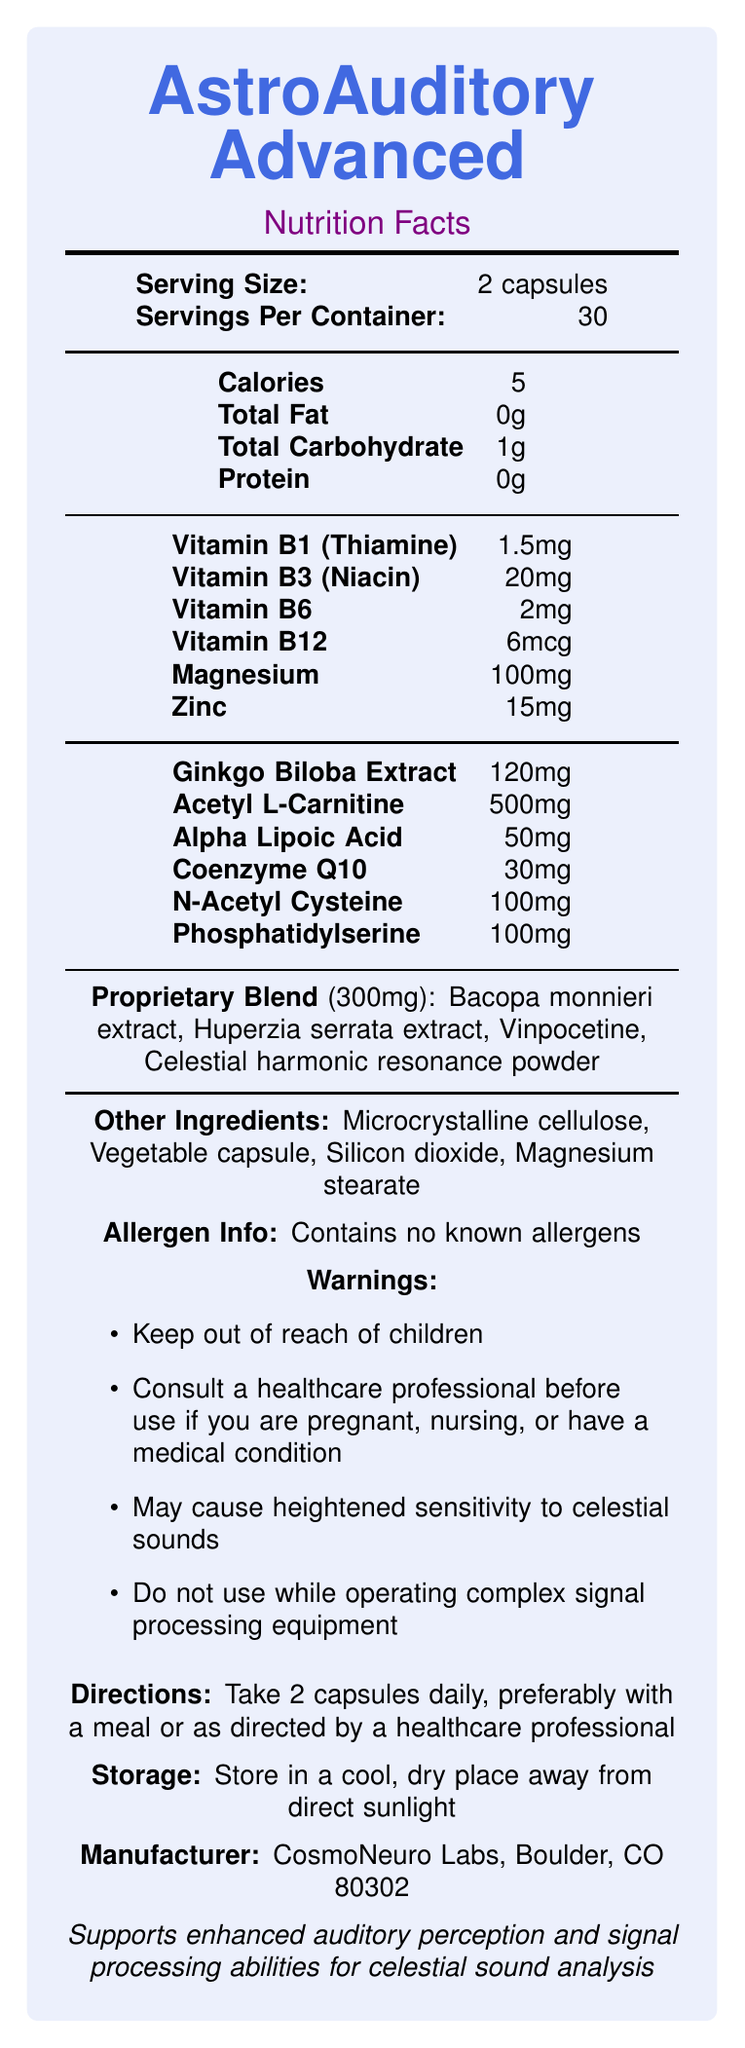what is the serving size? The serving size is clearly listed as "2 capsules" under the "Serving Size" section.
Answer: 2 capsules how many calories are in one serving? The calories per serving are listed as "5" in the Nutrition Facts section.
Answer: 5 which vitamins are included in the supplement? The listed vitamins under Nutrition Facts are Vitamin B1 (Thiamine), Vitamin B3 (Niacin), Vitamin B6, and Vitamin B12.
Answer: Vitamin B1 (Thiamine), Vitamin B3 (Niacin), Vitamin B6, Vitamin B12 how much Magnesium is in each serving? The amount of Magnesium per serving is stated as "100mg" in the Nutrition Facts section.
Answer: 100mg are there any known allergens in this supplement? The document explicitly states that the supplement "Contains no known allergens".
Answer: Contains no known allergens which of the following is part of the proprietary blend? A. Coenzyme Q10 B. Ginkgo Biloba Extract C. Vinpocetine Vinpocetine is listed as one of the components in the proprietary blend.
Answer: C. Vinpocetine how should the supplement be stored? A. In a warm place B. In a humid place C. In a cool, dry place The storage instructions specify that the supplement should be stored "in a cool, dry place away from direct sunlight."
Answer: C. In a cool, dry place can pregnant women take this supplement without consulting a healthcare professional? One of the listed warnings is to "consult a healthcare professional before use if you are pregnant".
Answer: No does this product contain protein? The Nutrition Facts indicate that the protein content per serving is "0g".
Answer: No how many capsules should be taken daily? The directions state to "Take 2 capsules daily".
Answer: 2 who is the manufacturer of this supplement? The manufacturer information provided is "CosmoNeuro Labs, Boulder, CO 80302".
Answer: CosmoNeuro Labs, Boulder, CO 80302 summarize the overall purpose of AstroAuditory Advanced. The document claims that AstroAuditory Advanced "supports enhanced auditory perception and signal processing abilities for celestial sound analysis."
Answer: Supports enhanced auditory perception and signal processing abilities for celestial sound analysis how many components are in the Proprietary Blend? The Proprietary Blend contains Bacopa monnieri extract, Huperzia serrata extract, Vinpocetine, and Celestial harmonic resonance powder, making a total of four components.
Answer: Four how many vitamins are listed in the Nutrition Facts section? The Nutrition Facts list four vitamins: Vitamin B1 (Thiamine), Vitamin B3 (Niacin), Vitamin B6, and Vitamin B12.
Answer: Four is there any claim about the impact on celestial sounds? The document mentions "may cause heightened sensitivity to celestial sounds" in the warnings section.
Answer: Yes what is the serving size for this supplement in capsules? The serving size section states that it is 2 capsules per serving.
Answer: 2 capsules how many servings are there in one container? A. 15 B. 30 C. 45 The section labeled "Servings Per Container" states that there are 30 servings in one container.
Answer: B. 30 how should you take the supplement? A. On an empty stomach B. With a meal C. Before bed The directions suggest taking the supplement "preferably with a meal or as directed by a healthcare professional."
Answer: B. With a meal which ingredient has the highest quantity per serving? The ingredient with the highest quantity per serving is Acetyl L-Carnitine at 500mg.
Answer: Acetyl L-Carnitine what is the color used for the text "AstroAuditory Advanced"? The document specifies that "AstroAuditory Advanced" is in celestial blue color.
Answer: Celestial blue 